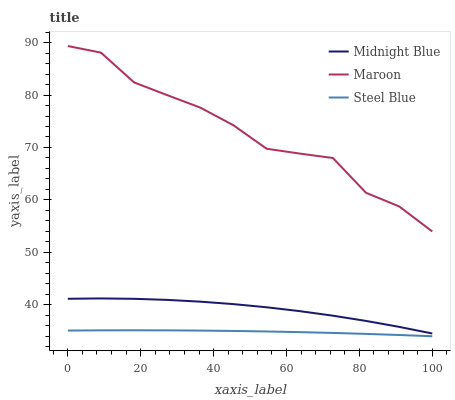Does Steel Blue have the minimum area under the curve?
Answer yes or no. Yes. Does Maroon have the maximum area under the curve?
Answer yes or no. Yes. Does Maroon have the minimum area under the curve?
Answer yes or no. No. Does Steel Blue have the maximum area under the curve?
Answer yes or no. No. Is Steel Blue the smoothest?
Answer yes or no. Yes. Is Maroon the roughest?
Answer yes or no. Yes. Is Maroon the smoothest?
Answer yes or no. No. Is Steel Blue the roughest?
Answer yes or no. No. Does Steel Blue have the lowest value?
Answer yes or no. Yes. Does Maroon have the lowest value?
Answer yes or no. No. Does Maroon have the highest value?
Answer yes or no. Yes. Does Steel Blue have the highest value?
Answer yes or no. No. Is Midnight Blue less than Maroon?
Answer yes or no. Yes. Is Maroon greater than Midnight Blue?
Answer yes or no. Yes. Does Midnight Blue intersect Maroon?
Answer yes or no. No. 